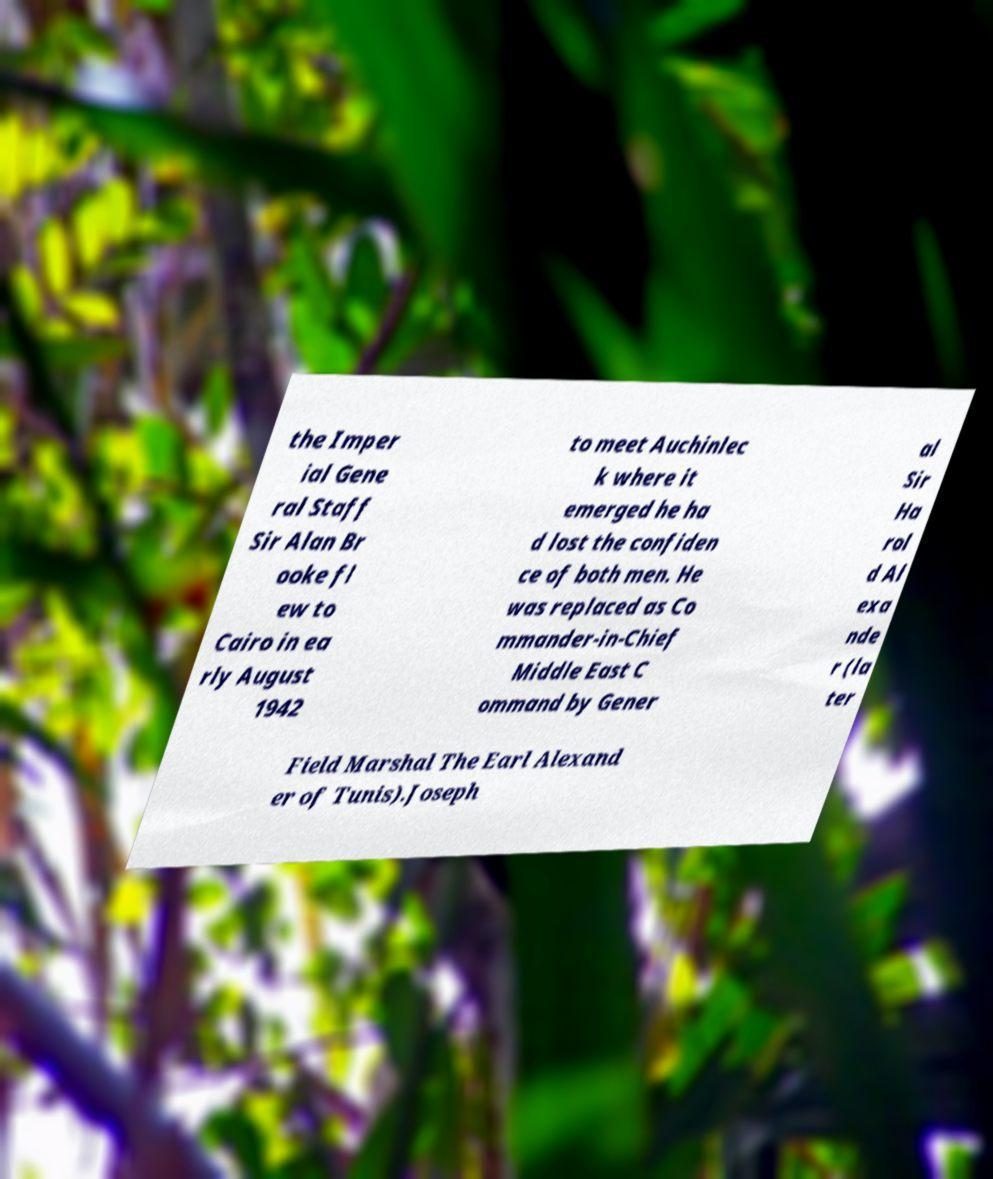Can you read and provide the text displayed in the image?This photo seems to have some interesting text. Can you extract and type it out for me? the Imper ial Gene ral Staff Sir Alan Br ooke fl ew to Cairo in ea rly August 1942 to meet Auchinlec k where it emerged he ha d lost the confiden ce of both men. He was replaced as Co mmander-in-Chief Middle East C ommand by Gener al Sir Ha rol d Al exa nde r (la ter Field Marshal The Earl Alexand er of Tunis).Joseph 